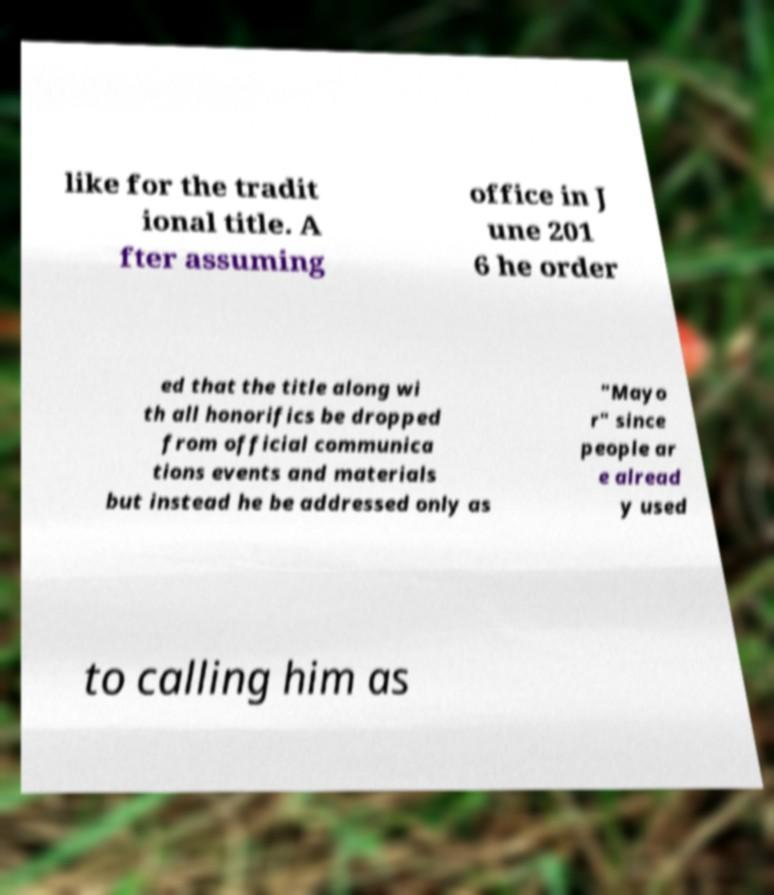Can you read and provide the text displayed in the image?This photo seems to have some interesting text. Can you extract and type it out for me? like for the tradit ional title. A fter assuming office in J une 201 6 he order ed that the title along wi th all honorifics be dropped from official communica tions events and materials but instead he be addressed only as "Mayo r" since people ar e alread y used to calling him as 